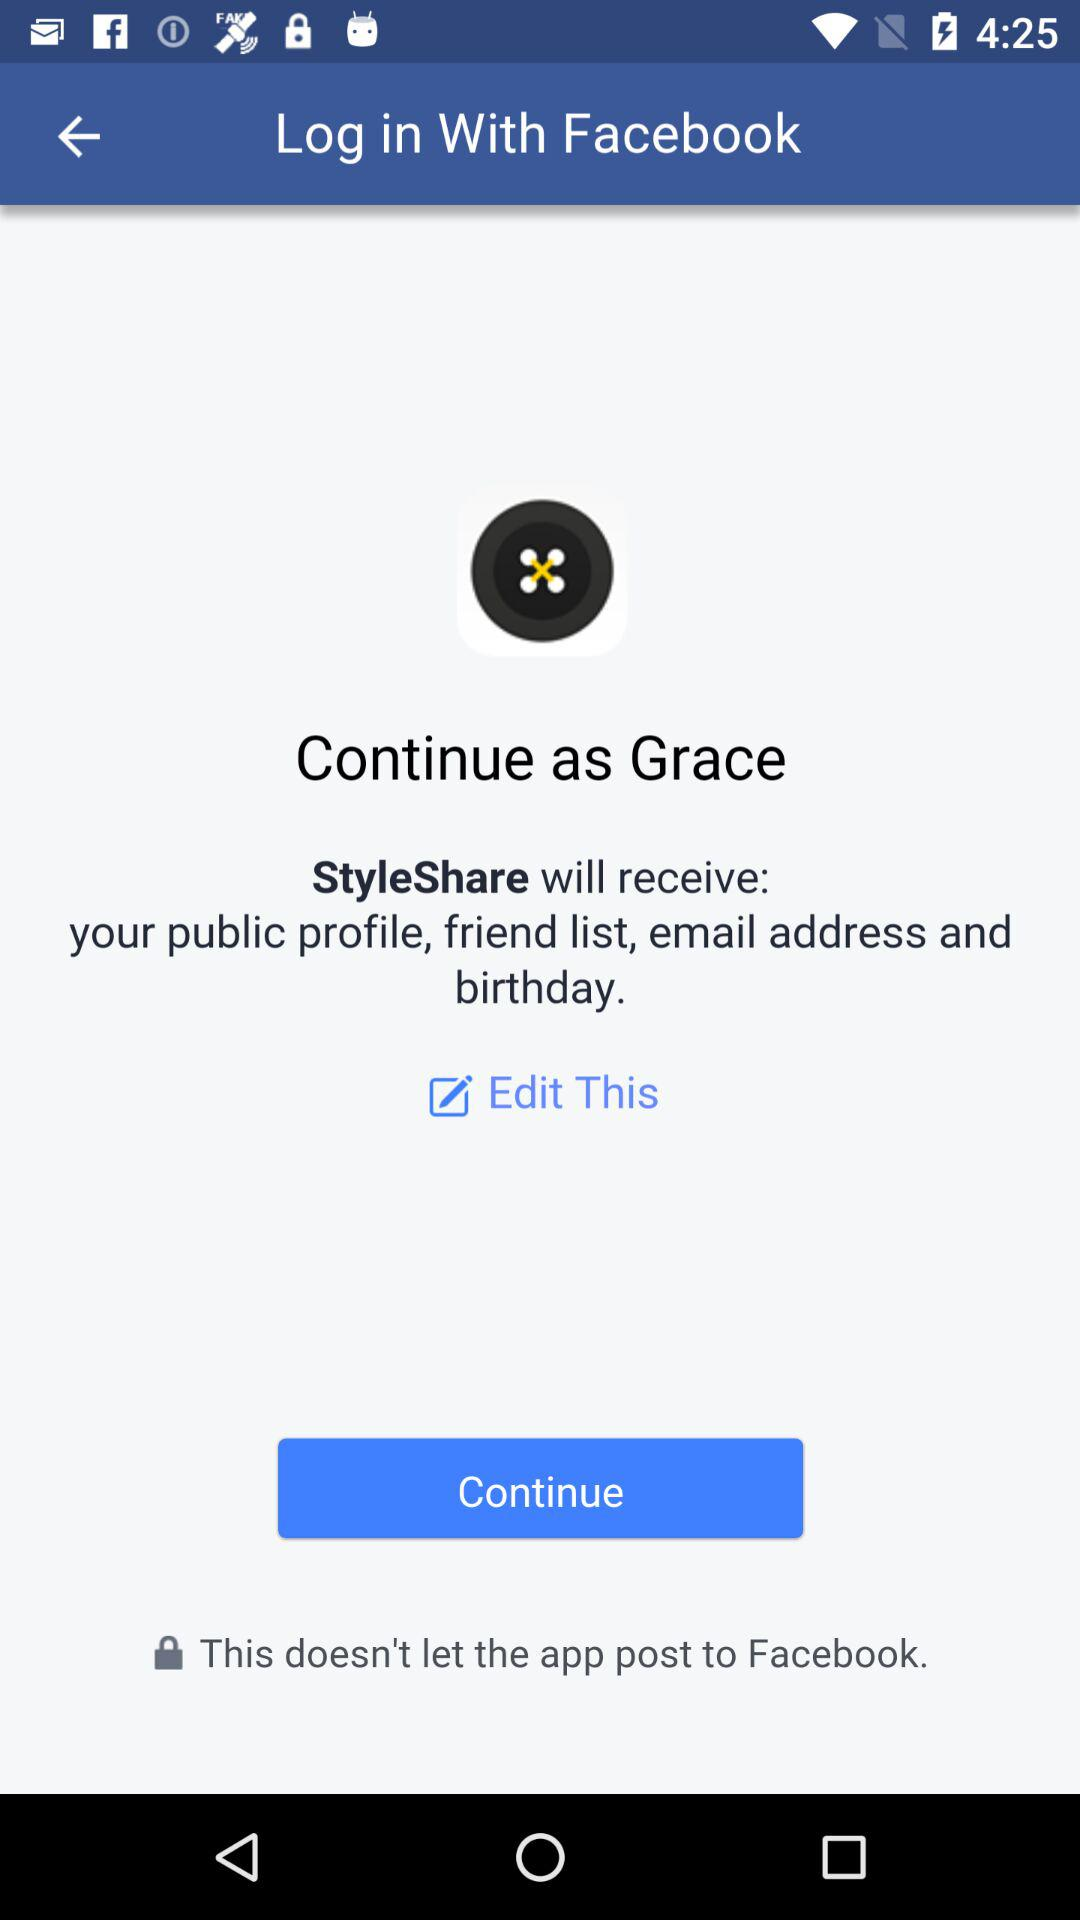What application is asking for permission? The application asking for permission is "StyleShare". 